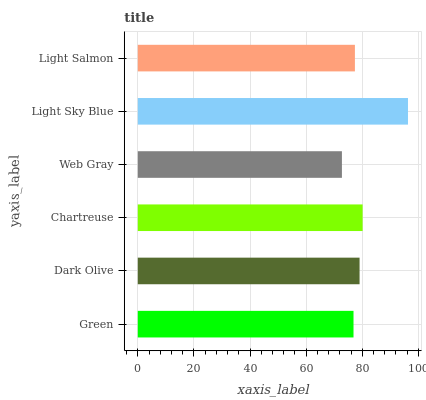Is Web Gray the minimum?
Answer yes or no. Yes. Is Light Sky Blue the maximum?
Answer yes or no. Yes. Is Dark Olive the minimum?
Answer yes or no. No. Is Dark Olive the maximum?
Answer yes or no. No. Is Dark Olive greater than Green?
Answer yes or no. Yes. Is Green less than Dark Olive?
Answer yes or no. Yes. Is Green greater than Dark Olive?
Answer yes or no. No. Is Dark Olive less than Green?
Answer yes or no. No. Is Dark Olive the high median?
Answer yes or no. Yes. Is Light Salmon the low median?
Answer yes or no. Yes. Is Chartreuse the high median?
Answer yes or no. No. Is Dark Olive the low median?
Answer yes or no. No. 